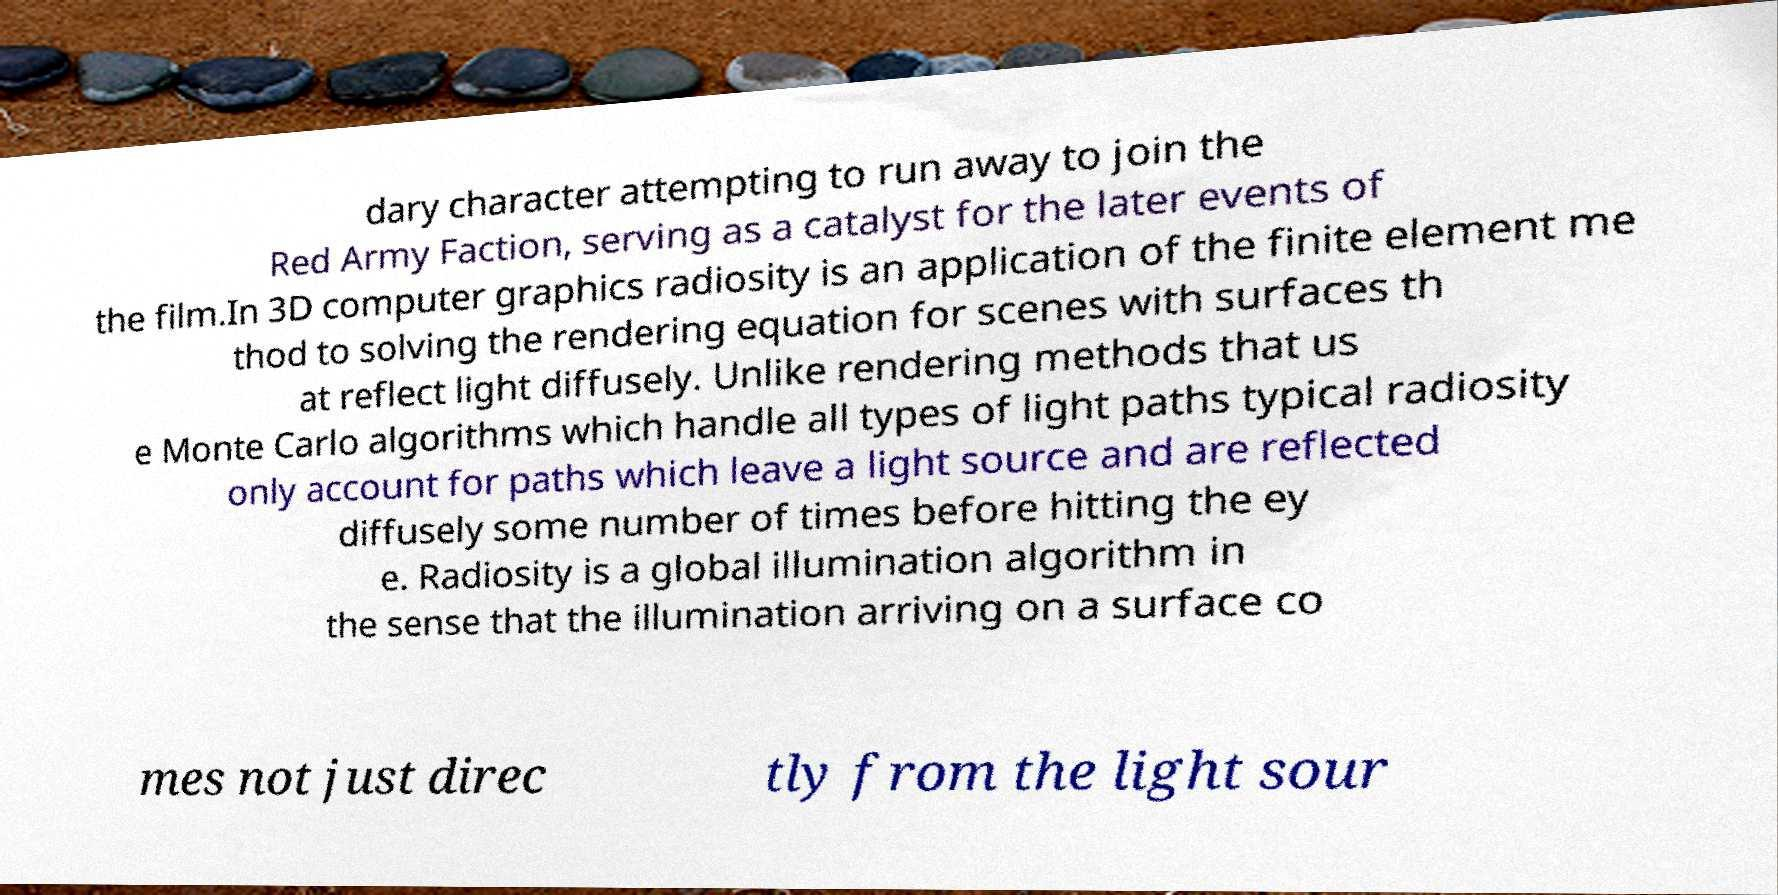Please identify and transcribe the text found in this image. dary character attempting to run away to join the Red Army Faction, serving as a catalyst for the later events of the film.In 3D computer graphics radiosity is an application of the finite element me thod to solving the rendering equation for scenes with surfaces th at reflect light diffusely. Unlike rendering methods that us e Monte Carlo algorithms which handle all types of light paths typical radiosity only account for paths which leave a light source and are reflected diffusely some number of times before hitting the ey e. Radiosity is a global illumination algorithm in the sense that the illumination arriving on a surface co mes not just direc tly from the light sour 